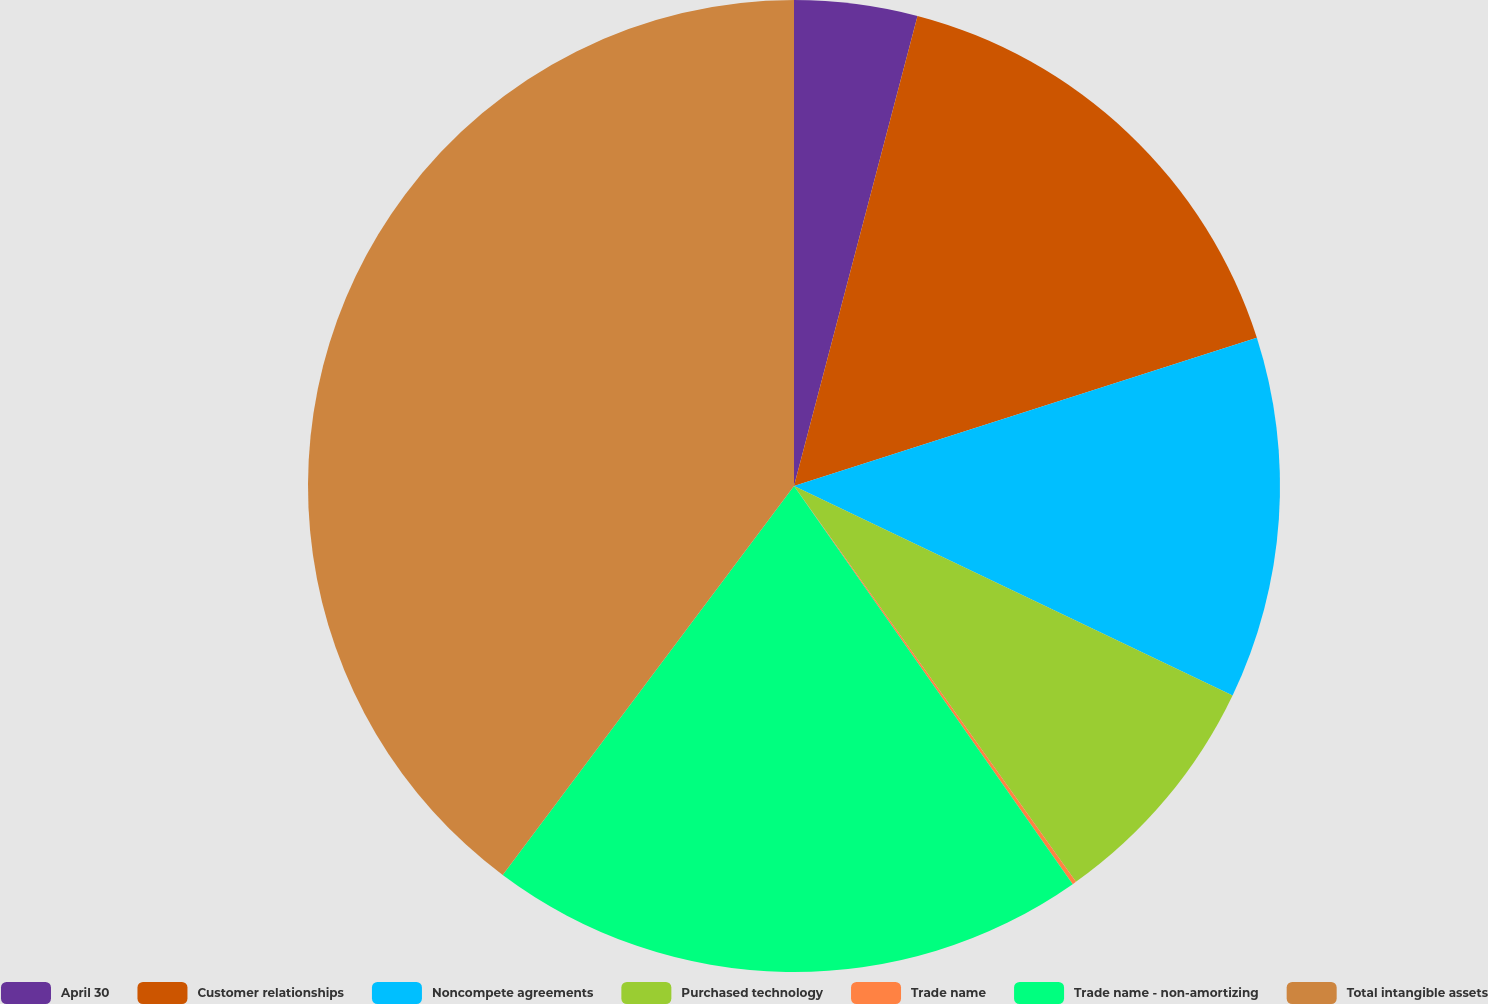Convert chart. <chart><loc_0><loc_0><loc_500><loc_500><pie_chart><fcel>April 30<fcel>Customer relationships<fcel>Noncompete agreements<fcel>Purchased technology<fcel>Trade name<fcel>Trade name - non-amortizing<fcel>Total intangible assets<nl><fcel>4.09%<fcel>15.98%<fcel>12.02%<fcel>8.06%<fcel>0.13%<fcel>19.95%<fcel>39.77%<nl></chart> 